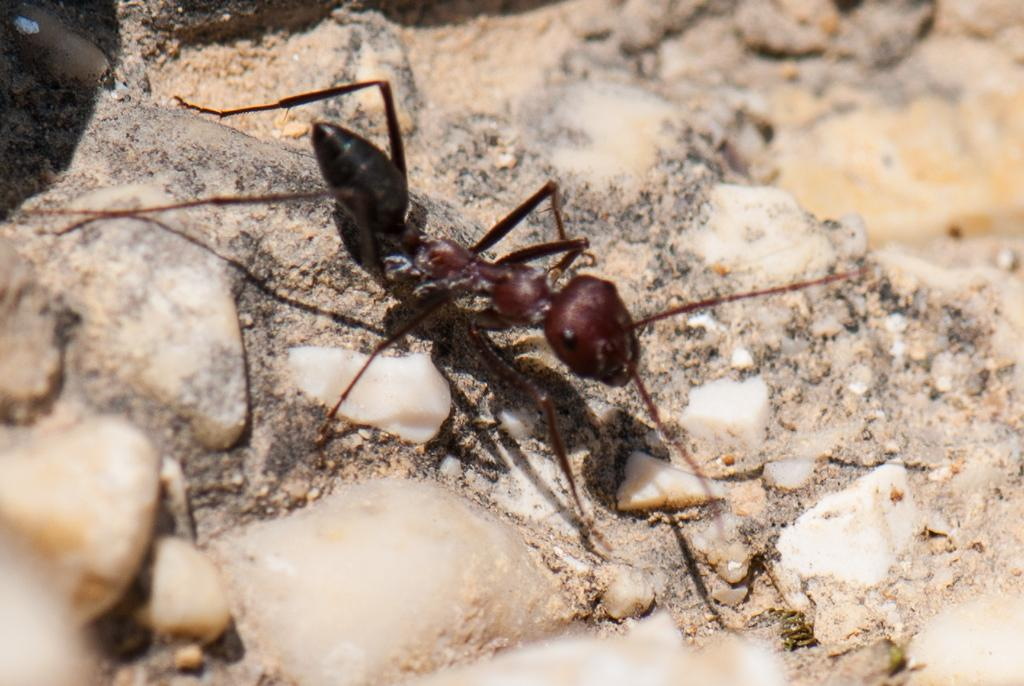What type of creature is present in the image? There is an ant in the image. What is the color of the ant? The ant is black in color. What type of liquid is the ant using to develop its wings in the image? There is no liquid or development of wings visible in the image; it only shows a black ant. 